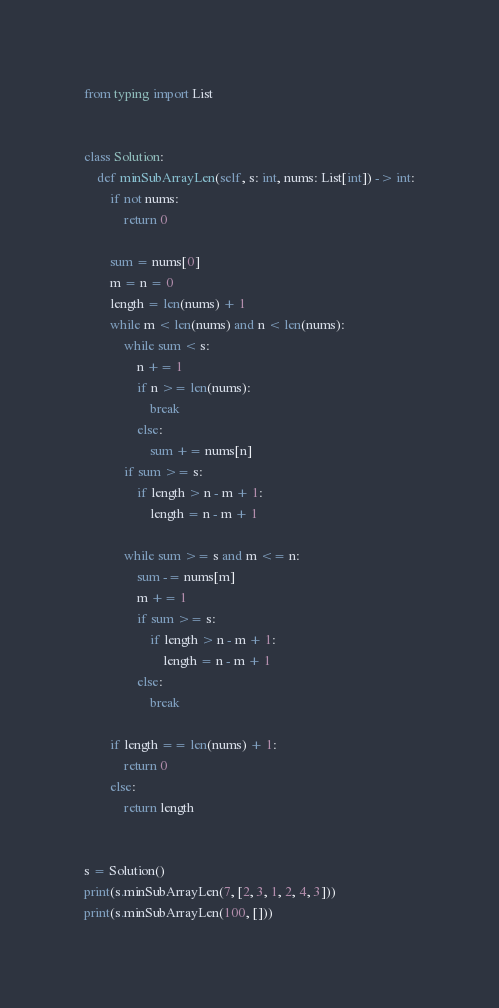Convert code to text. <code><loc_0><loc_0><loc_500><loc_500><_Python_>from typing import List


class Solution:
    def minSubArrayLen(self, s: int, nums: List[int]) -> int:
        if not nums:
            return 0

        sum = nums[0]
        m = n = 0
        length = len(nums) + 1
        while m < len(nums) and n < len(nums):
            while sum < s:
                n += 1
                if n >= len(nums):
                    break
                else:
                    sum += nums[n]
            if sum >= s:
                if length > n - m + 1:
                    length = n - m + 1

            while sum >= s and m <= n:
                sum -= nums[m]
                m += 1
                if sum >= s:
                    if length > n - m + 1:
                        length = n - m + 1
                else:
                    break

        if length == len(nums) + 1:
            return 0
        else:
            return length


s = Solution()
print(s.minSubArrayLen(7, [2, 3, 1, 2, 4, 3]))
print(s.minSubArrayLen(100, []))
</code> 